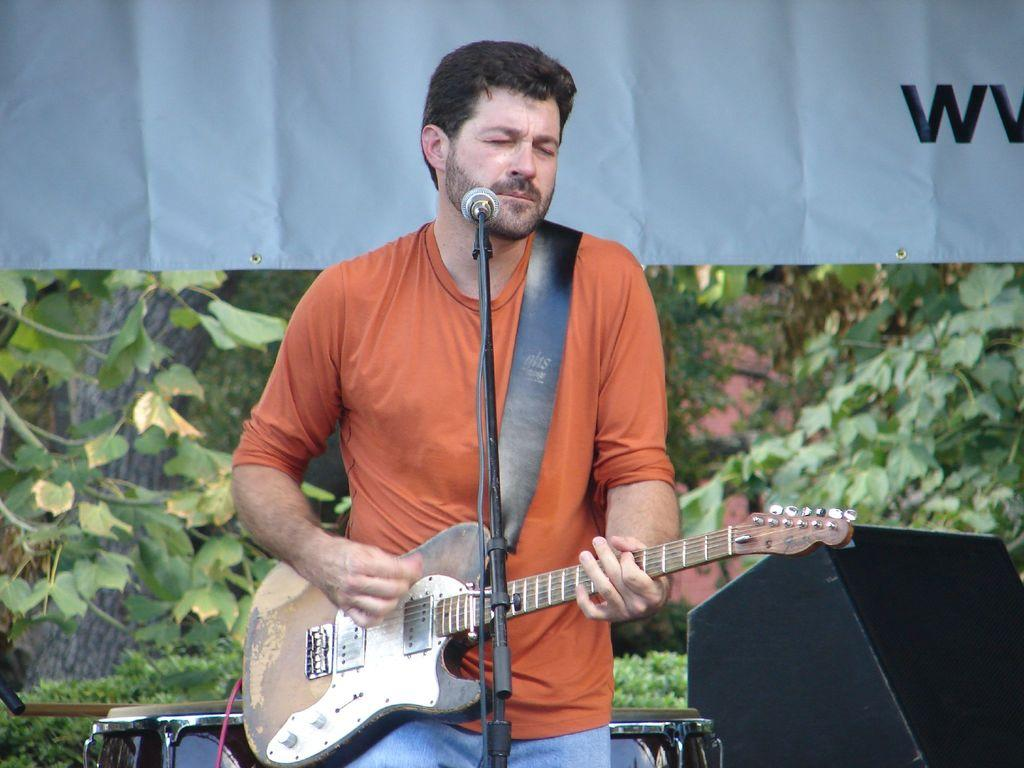What is the man in the image doing? The man is playing a guitar in the image. What other musical instruments can be seen in the image? There are drums in the background of the image. What objects are present in the background of the image? There is a speaker, a tree, and a banner in the background of the image. What type of linen is draped over the guitar in the image? There is no linen draped over the guitar in the image. Can you see a giraffe in the background of the image? No, there is no giraffe present in the image. 